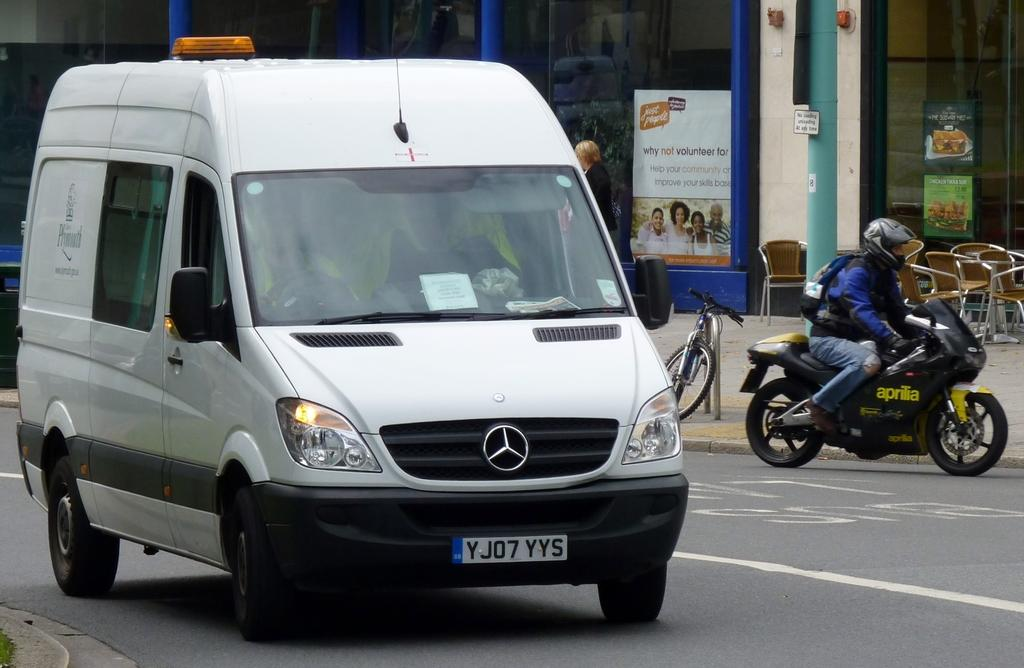<image>
Provide a brief description of the given image. A Mercedes Benz van with license plate YJO7YYS is driving on the road. 